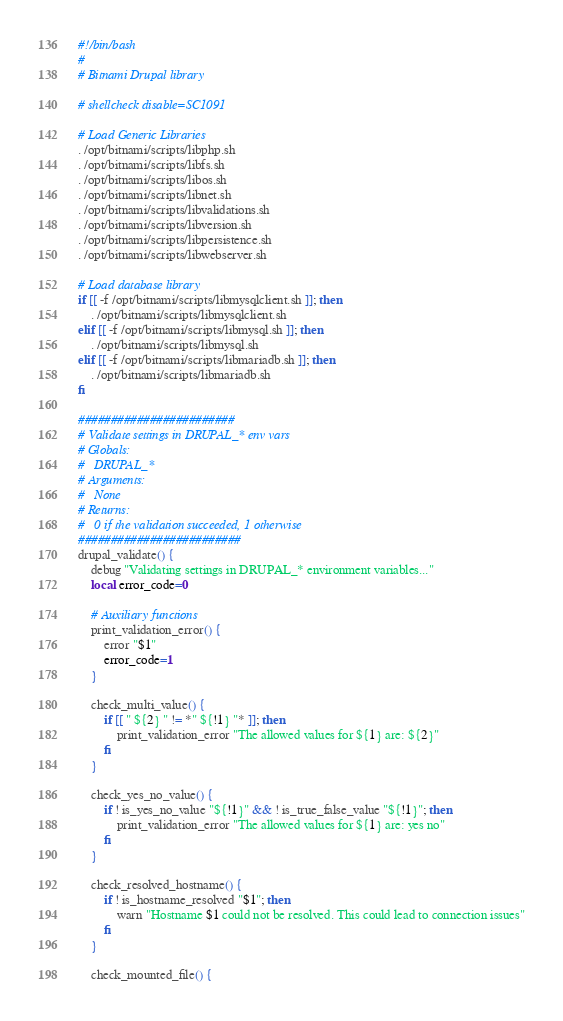Convert code to text. <code><loc_0><loc_0><loc_500><loc_500><_Bash_>#!/bin/bash
#
# Bitnami Drupal library

# shellcheck disable=SC1091

# Load Generic Libraries
. /opt/bitnami/scripts/libphp.sh
. /opt/bitnami/scripts/libfs.sh
. /opt/bitnami/scripts/libos.sh
. /opt/bitnami/scripts/libnet.sh
. /opt/bitnami/scripts/libvalidations.sh
. /opt/bitnami/scripts/libversion.sh
. /opt/bitnami/scripts/libpersistence.sh
. /opt/bitnami/scripts/libwebserver.sh

# Load database library
if [[ -f /opt/bitnami/scripts/libmysqlclient.sh ]]; then
    . /opt/bitnami/scripts/libmysqlclient.sh
elif [[ -f /opt/bitnami/scripts/libmysql.sh ]]; then
    . /opt/bitnami/scripts/libmysql.sh
elif [[ -f /opt/bitnami/scripts/libmariadb.sh ]]; then
    . /opt/bitnami/scripts/libmariadb.sh
fi

########################
# Validate settings in DRUPAL_* env vars
# Globals:
#   DRUPAL_*
# Arguments:
#   None
# Returns:
#   0 if the validation succeeded, 1 otherwise
#########################
drupal_validate() {
    debug "Validating settings in DRUPAL_* environment variables..."
    local error_code=0

    # Auxiliary functions
    print_validation_error() {
        error "$1"
        error_code=1
    }

    check_multi_value() {
        if [[ " ${2} " != *" ${!1} "* ]]; then
            print_validation_error "The allowed values for ${1} are: ${2}"
        fi
    }

    check_yes_no_value() {
        if ! is_yes_no_value "${!1}" && ! is_true_false_value "${!1}"; then
            print_validation_error "The allowed values for ${1} are: yes no"
        fi
    }

    check_resolved_hostname() {
        if ! is_hostname_resolved "$1"; then
            warn "Hostname $1 could not be resolved. This could lead to connection issues"
        fi
    }

    check_mounted_file() {</code> 